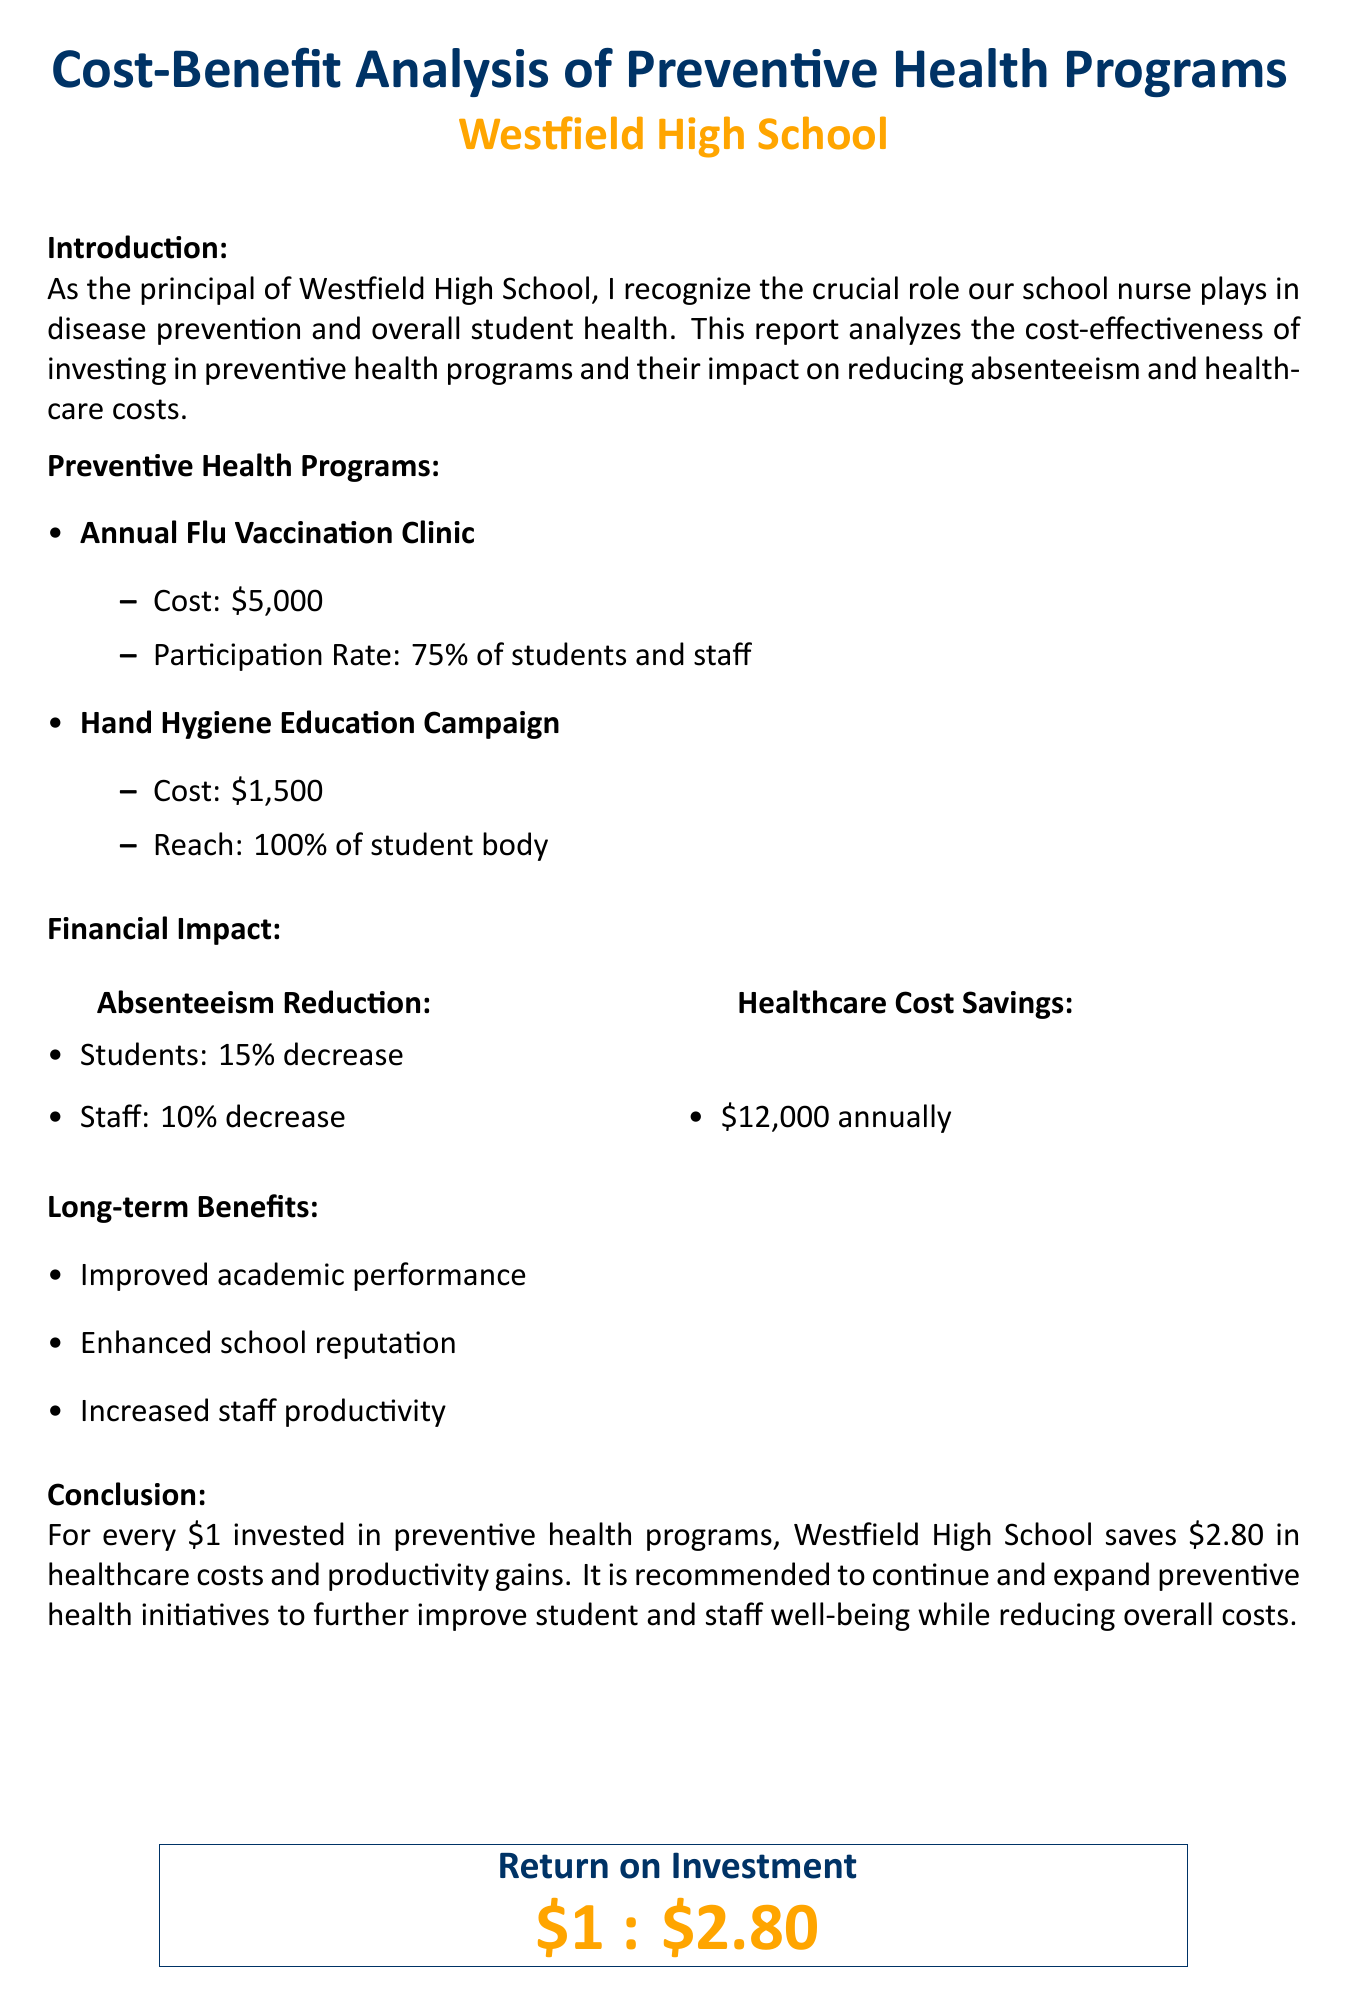What is the title of the report? The title is stated in the header of the document, which summarizes the content.
Answer: Cost-Benefit Analysis of Preventive Health Programs in Westfield High School What is the cost of the Annual Flu Vaccination Clinic? The cost is clearly listed under the preventive health programs section in the report.
Answer: $5,000 What percentage of students and staff participate in the Annual Flu Vaccination Clinic? This information is provided next to the cost of the program, detailing participation.
Answer: 75% of students and staff How much does the Hand Hygiene Education Campaign cost? The cost of this specific program is mentioned in the preventive health programs section.
Answer: $1,500 What is the annual healthcare cost savings? The annual savings is detailed in the financial impact section of the report.
Answer: $12,000 annually What is the percentage decrease in student absenteeism? This percentage is provided in the financial impact section related to absenteeism reduction.
Answer: 15% decrease What long-term benefit is mentioned related to academic performance? This benefit is listed in the long-term benefits section, summarizing the positive outcomes of the programs.
Answer: Improved academic performance What is the return on investment for every dollar spent on preventive health programs? The conclusion states this ratio, summarizing the financial effectiveness of the programs.
Answer: $1 : $2.80 What is the recommendation given in the conclusion? The recommendation is highlighted in the conclusion section, suggesting the future course of action.
Answer: Continue and expand preventive health initiatives 